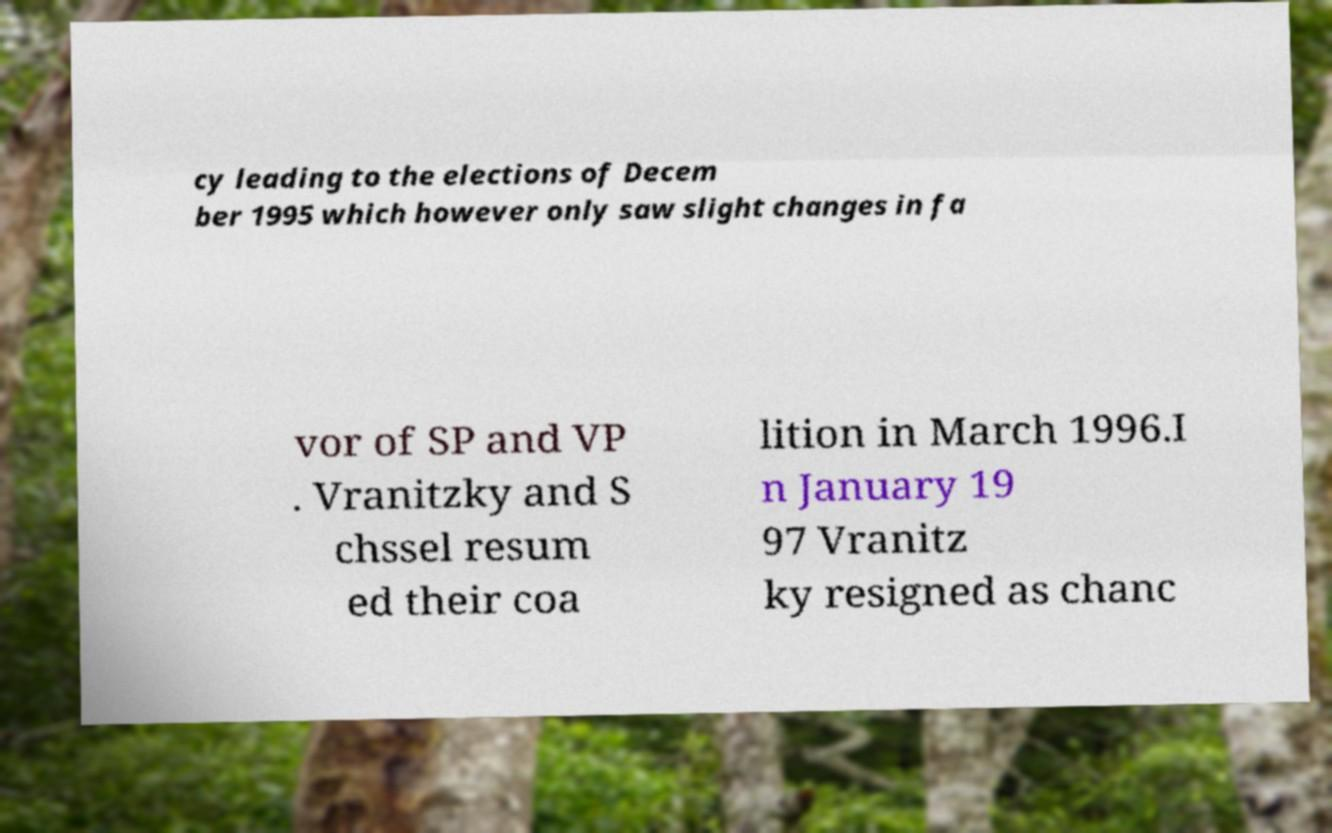I need the written content from this picture converted into text. Can you do that? cy leading to the elections of Decem ber 1995 which however only saw slight changes in fa vor of SP and VP . Vranitzky and S chssel resum ed their coa lition in March 1996.I n January 19 97 Vranitz ky resigned as chanc 